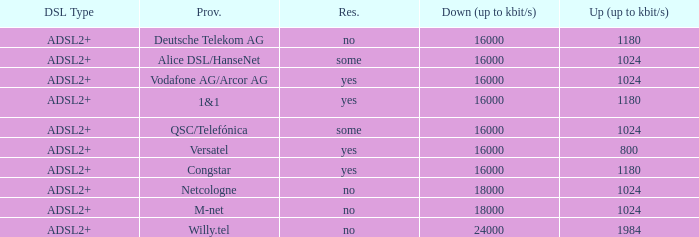What are all the dsl type offered by the M-Net telecom company? ADSL2+. 